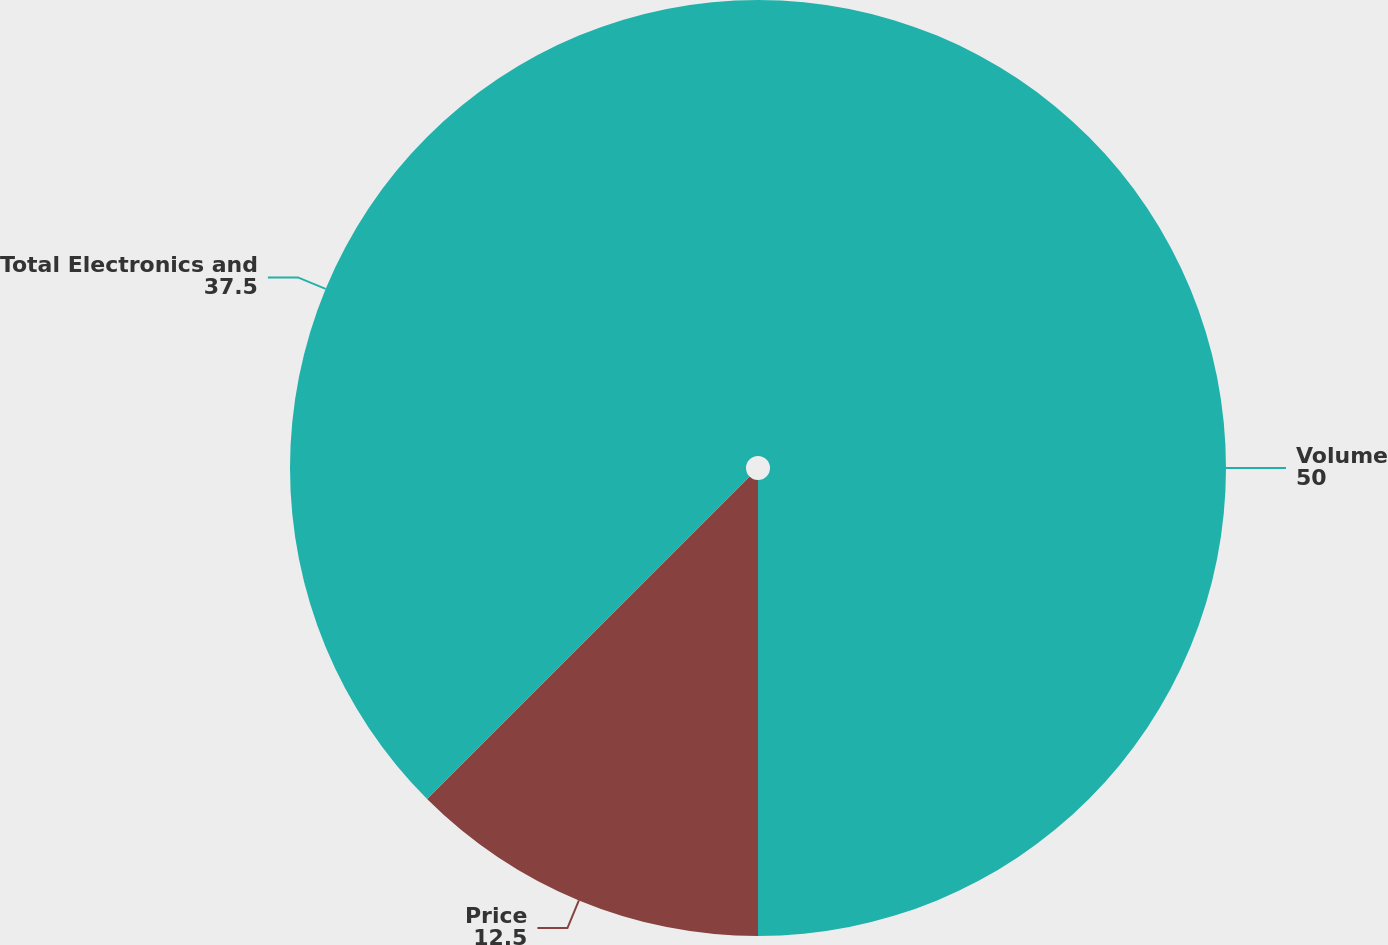Convert chart to OTSL. <chart><loc_0><loc_0><loc_500><loc_500><pie_chart><fcel>Volume<fcel>Price<fcel>Total Electronics and<nl><fcel>50.0%<fcel>12.5%<fcel>37.5%<nl></chart> 